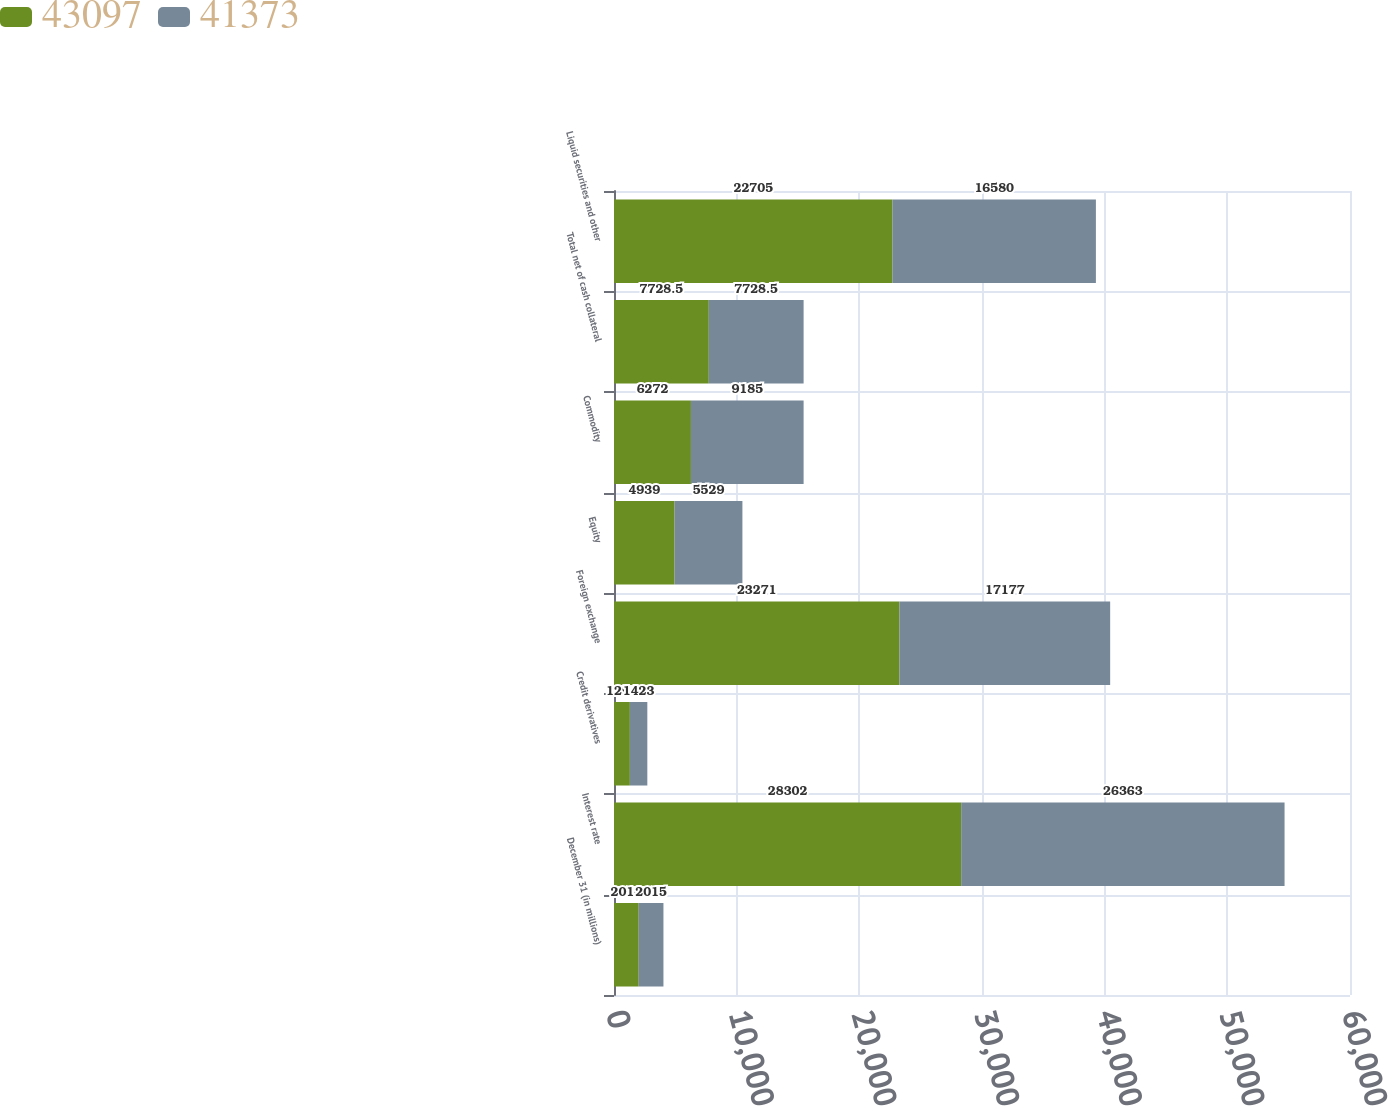<chart> <loc_0><loc_0><loc_500><loc_500><stacked_bar_chart><ecel><fcel>December 31 (in millions)<fcel>Interest rate<fcel>Credit derivatives<fcel>Foreign exchange<fcel>Equity<fcel>Commodity<fcel>Total net of cash collateral<fcel>Liquid securities and other<nl><fcel>43097<fcel>2016<fcel>28302<fcel>1294<fcel>23271<fcel>4939<fcel>6272<fcel>7728.5<fcel>22705<nl><fcel>41373<fcel>2015<fcel>26363<fcel>1423<fcel>17177<fcel>5529<fcel>9185<fcel>7728.5<fcel>16580<nl></chart> 